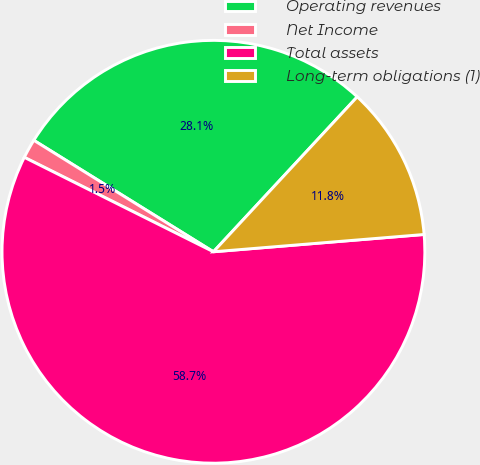<chart> <loc_0><loc_0><loc_500><loc_500><pie_chart><fcel>Operating revenues<fcel>Net Income<fcel>Total assets<fcel>Long-term obligations (1)<nl><fcel>28.07%<fcel>1.47%<fcel>58.68%<fcel>11.79%<nl></chart> 